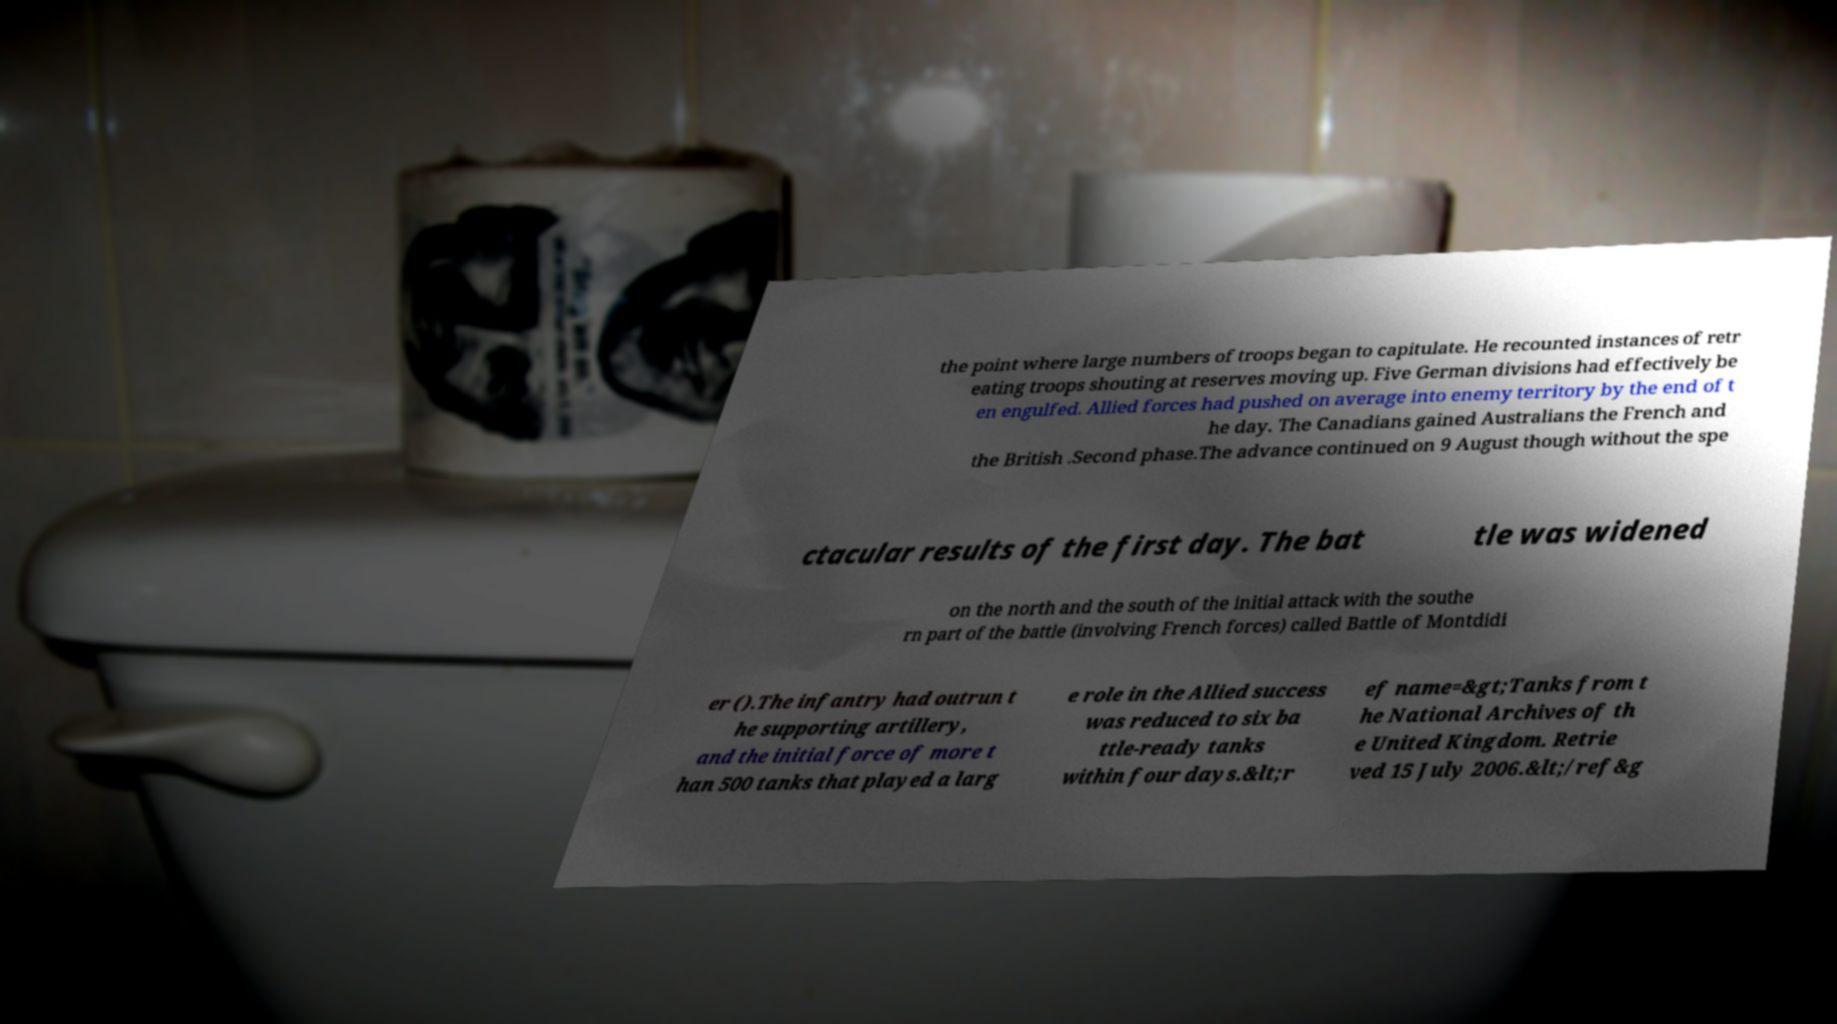I need the written content from this picture converted into text. Can you do that? the point where large numbers of troops began to capitulate. He recounted instances of retr eating troops shouting at reserves moving up. Five German divisions had effectively be en engulfed. Allied forces had pushed on average into enemy territory by the end of t he day. The Canadians gained Australians the French and the British .Second phase.The advance continued on 9 August though without the spe ctacular results of the first day. The bat tle was widened on the north and the south of the initial attack with the southe rn part of the battle (involving French forces) called Battle of Montdidi er ().The infantry had outrun t he supporting artillery, and the initial force of more t han 500 tanks that played a larg e role in the Allied success was reduced to six ba ttle-ready tanks within four days.&lt;r ef name=&gt;Tanks from t he National Archives of th e United Kingdom. Retrie ved 15 July 2006.&lt;/ref&g 